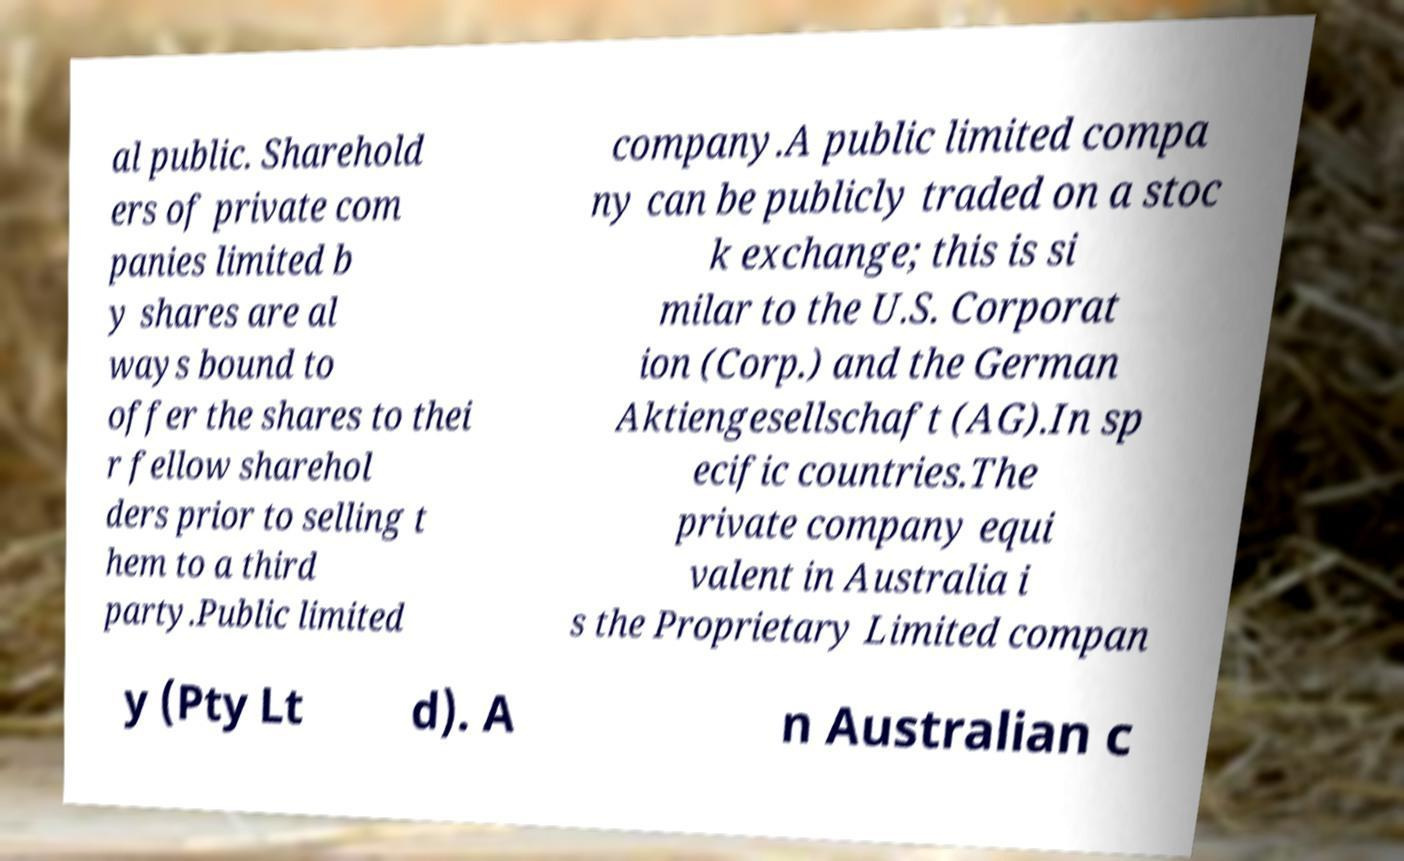There's text embedded in this image that I need extracted. Can you transcribe it verbatim? al public. Sharehold ers of private com panies limited b y shares are al ways bound to offer the shares to thei r fellow sharehol ders prior to selling t hem to a third party.Public limited company.A public limited compa ny can be publicly traded on a stoc k exchange; this is si milar to the U.S. Corporat ion (Corp.) and the German Aktiengesellschaft (AG).In sp ecific countries.The private company equi valent in Australia i s the Proprietary Limited compan y (Pty Lt d). A n Australian c 